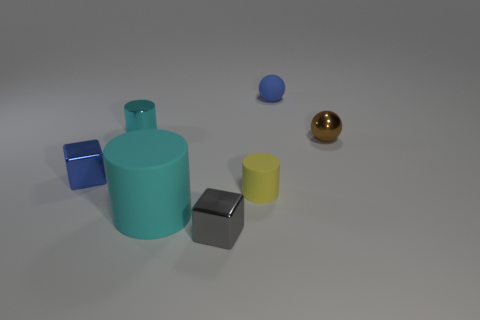There is a thing that is to the left of the cyan matte thing and on the right side of the tiny blue metal thing; how big is it?
Make the answer very short. Small. Are the large cylinder and the cyan cylinder that is behind the tiny blue cube made of the same material?
Ensure brevity in your answer.  No. What number of small things have the same shape as the large thing?
Give a very brief answer. 2. What is the material of the tiny thing that is the same color as the big rubber cylinder?
Ensure brevity in your answer.  Metal. What number of tiny cubes are there?
Your response must be concise. 2. Does the brown metal thing have the same shape as the metallic thing that is to the left of the small cyan object?
Provide a short and direct response. No. How many objects are either large purple cylinders or tiny shiny cylinders behind the big cylinder?
Ensure brevity in your answer.  1. There is another small object that is the same shape as the brown object; what is its material?
Your answer should be compact. Rubber. Is the shape of the shiny object that is to the right of the gray metal object the same as  the large rubber object?
Give a very brief answer. No. Are there any other things that are the same size as the metallic ball?
Your response must be concise. Yes. 